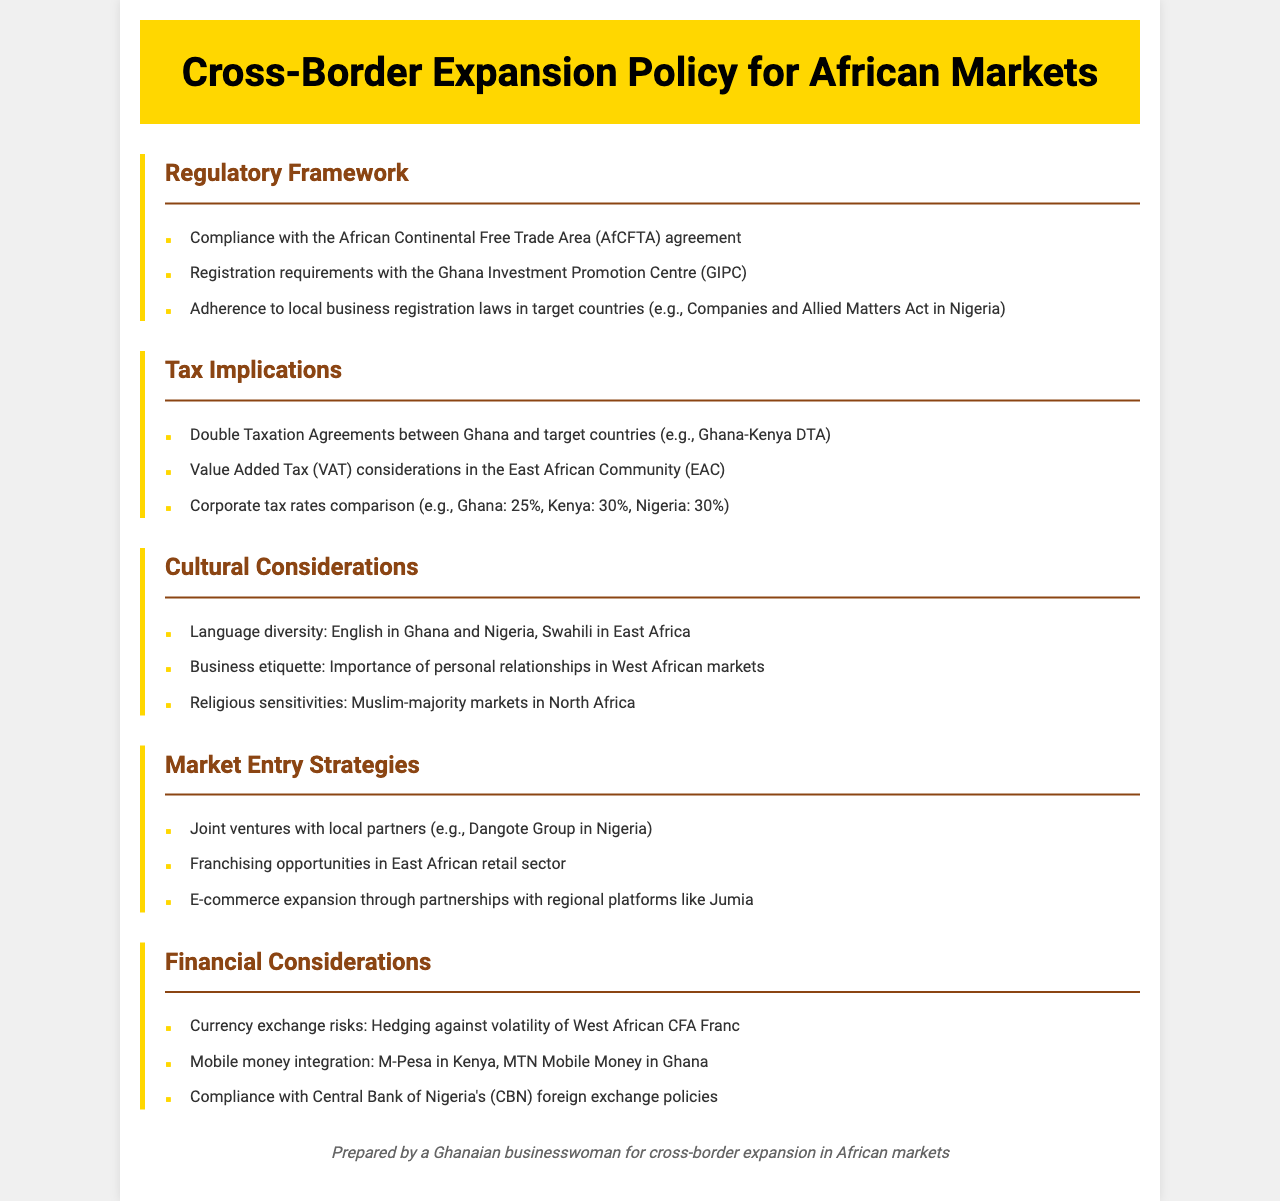What is the main regulatory agreement mentioned? The main regulatory agreement is the African Continental Free Trade Area (AfCFTA) which is essential for compliance in cross-border expansion.
Answer: AfCFTA What is the corporate tax rate in Ghana? The corporate tax rate in Ghana is listed as 25% in the tax implications section of the document.
Answer: 25% What language is predominantly spoken in East Africa? The document reflects that Swahili is predominantly spoken in East Africa, highlighting linguistic diversity in cultural considerations.
Answer: Swahili Which market entry strategy involves local partners? The strategy that involves local partners is joint ventures, as explicitly stated in the Market Entry Strategies section of the document.
Answer: Joint ventures What financial risk is associated with currency? The document mentions currency exchange risks related to the volatility of the West African CFA Franc, indicating a significant financial consideration.
Answer: CFA Franc How many countries are compared for corporate tax rates? The document compares corporate tax rates for three countries including Ghana, Kenya, and Nigeria, emphasizing regional tax implications.
Answer: Three What does the document suggest integrating for mobile payments? The document suggests integrating mobile money solutions like M-Pesa in Kenya and MTN Mobile Money in Ghana for financial considerations.
Answer: M-Pesa Which business aspect is emphasized in West African etiquette? The importance of personal relationships is emphasized as a key aspect of business etiquette in West African markets, reflecting cultural considerations.
Answer: Personal relationships What is a retail sector opportunity mentioned for East Africa? The document highlights franchising opportunities in the retail sector as a potential market entry strategy in East Africa.
Answer: Franchising What is the implication of the Double Taxation Agreements? The Double Taxation Agreements, such as the Ghana-Kenya DTA, play a crucial role in tax implications for businesses looking to expand across borders.
Answer: Ghana-Kenya DTA 